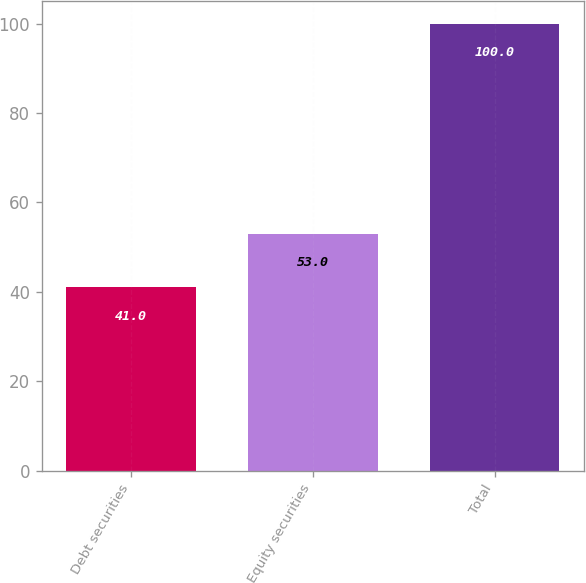Convert chart to OTSL. <chart><loc_0><loc_0><loc_500><loc_500><bar_chart><fcel>Debt securities<fcel>Equity securities<fcel>Total<nl><fcel>41<fcel>53<fcel>100<nl></chart> 